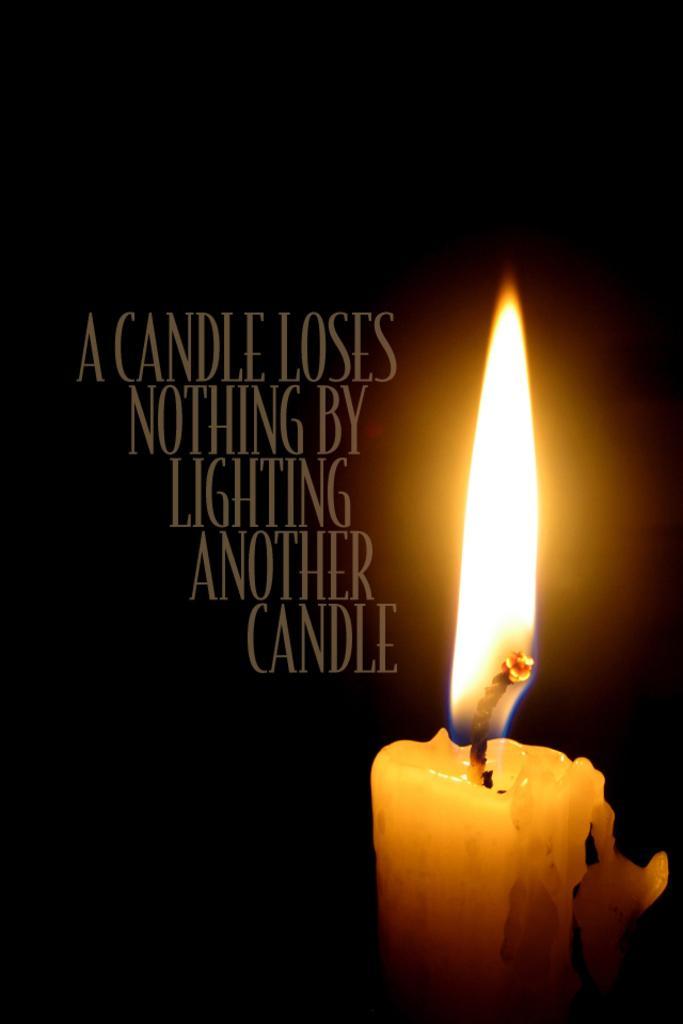Could you give a brief overview of what you see in this image? This picture looks like a poster I can see a candle and text and I can see dark background. 